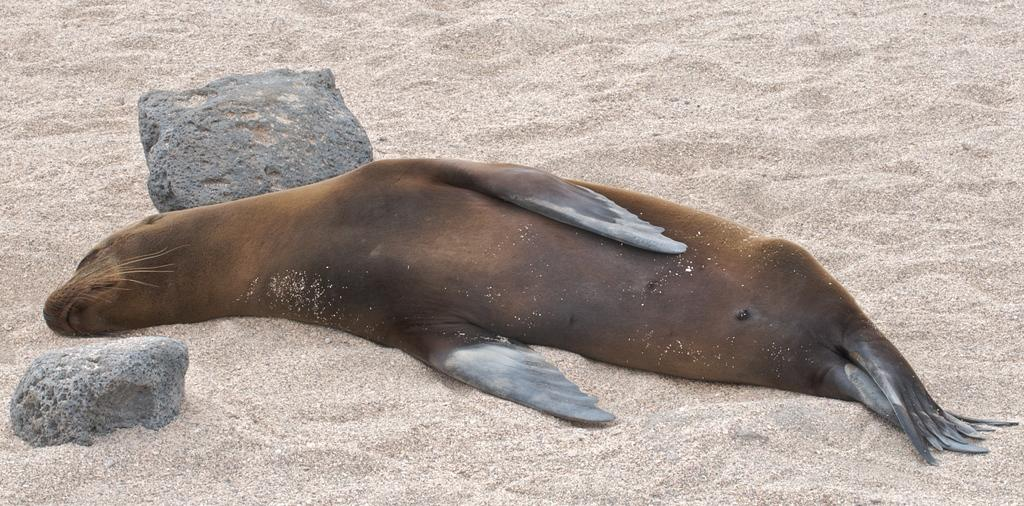What animal is present in the image? There is a seal in the image. Where is the seal located? The seal is laying on the beach. What objects are present near the seal? There are two stones on either side of the seal. What type of tooth can be seen in the image? There is no tooth present in the image. What kind of marble is visible in the image? There is no marble present in the image. 